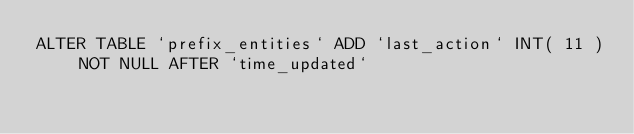Convert code to text. <code><loc_0><loc_0><loc_500><loc_500><_SQL_>ALTER TABLE `prefix_entities` ADD `last_action` INT( 11 ) NOT NULL AFTER `time_updated` 
</code> 